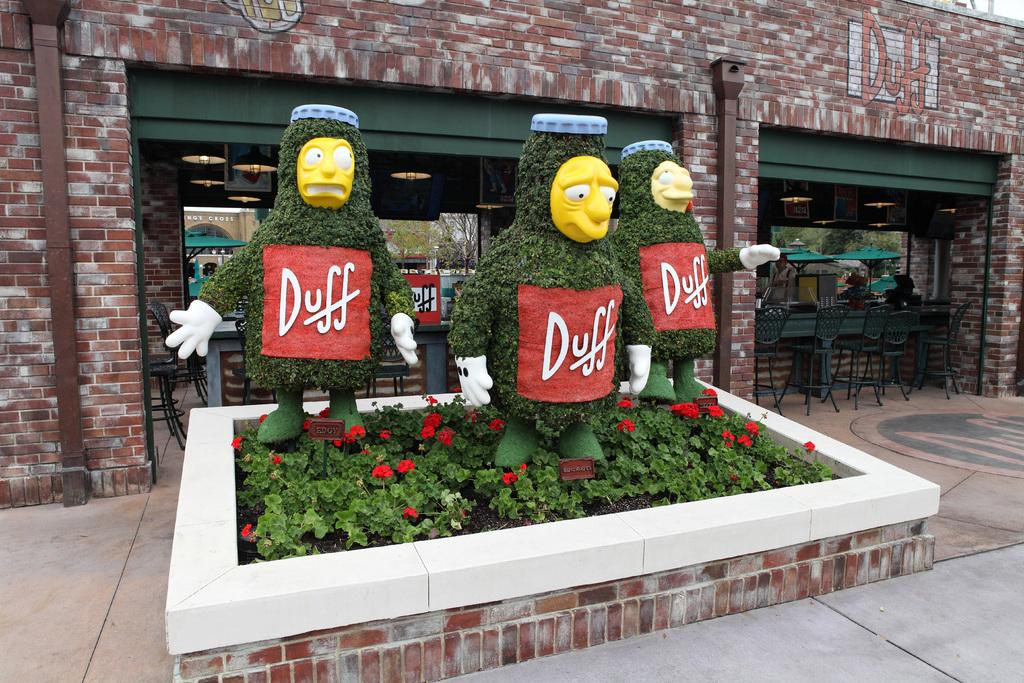<image>
Create a compact narrative representing the image presented. A sign for Duff is on the building and on three figures out front. 